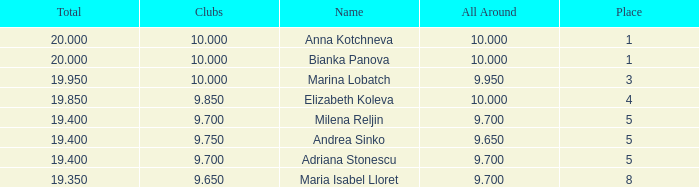What are the lowest clubs that have a place greater than 5, with an all around greater than 9.7? None. 